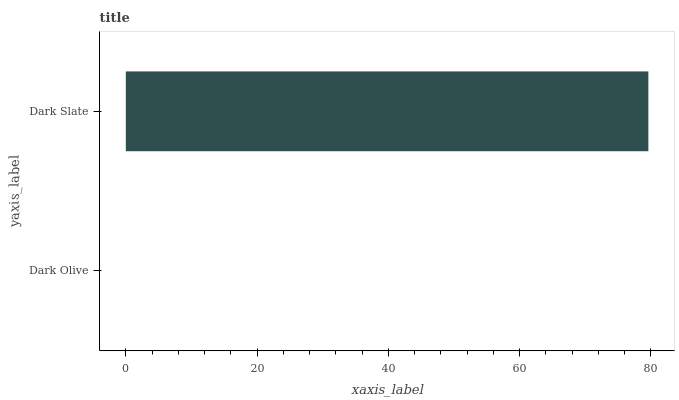Is Dark Olive the minimum?
Answer yes or no. Yes. Is Dark Slate the maximum?
Answer yes or no. Yes. Is Dark Slate the minimum?
Answer yes or no. No. Is Dark Slate greater than Dark Olive?
Answer yes or no. Yes. Is Dark Olive less than Dark Slate?
Answer yes or no. Yes. Is Dark Olive greater than Dark Slate?
Answer yes or no. No. Is Dark Slate less than Dark Olive?
Answer yes or no. No. Is Dark Slate the high median?
Answer yes or no. Yes. Is Dark Olive the low median?
Answer yes or no. Yes. Is Dark Olive the high median?
Answer yes or no. No. Is Dark Slate the low median?
Answer yes or no. No. 